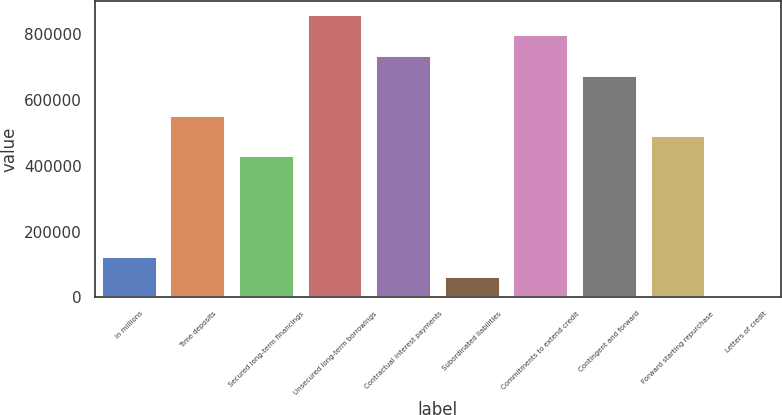Convert chart to OTSL. <chart><loc_0><loc_0><loc_500><loc_500><bar_chart><fcel>in millions<fcel>Time deposits<fcel>Secured long-term financings<fcel>Unsecured long-term borrowings<fcel>Contractual interest payments<fcel>Subordinated liabilities<fcel>Commitments to extend credit<fcel>Contingent and forward<fcel>Forward starting repurchase<fcel>Letters of credit<nl><fcel>122793<fcel>551492<fcel>429007<fcel>857706<fcel>735220<fcel>61550.7<fcel>796463<fcel>673978<fcel>490250<fcel>308<nl></chart> 